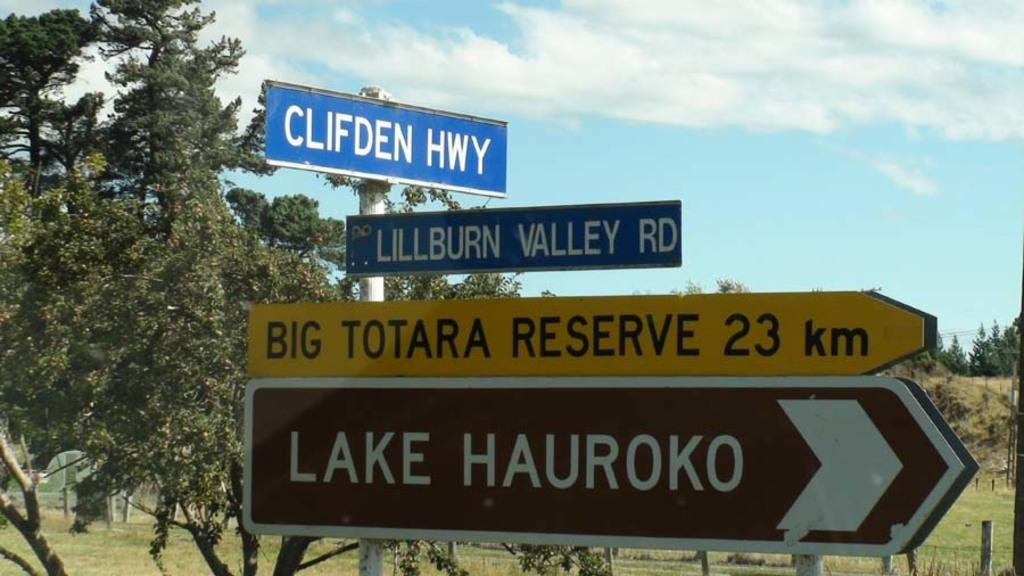Provide a one-sentence caption for the provided image. Many street signs such as, Clifden HWY are on the side of a road. 